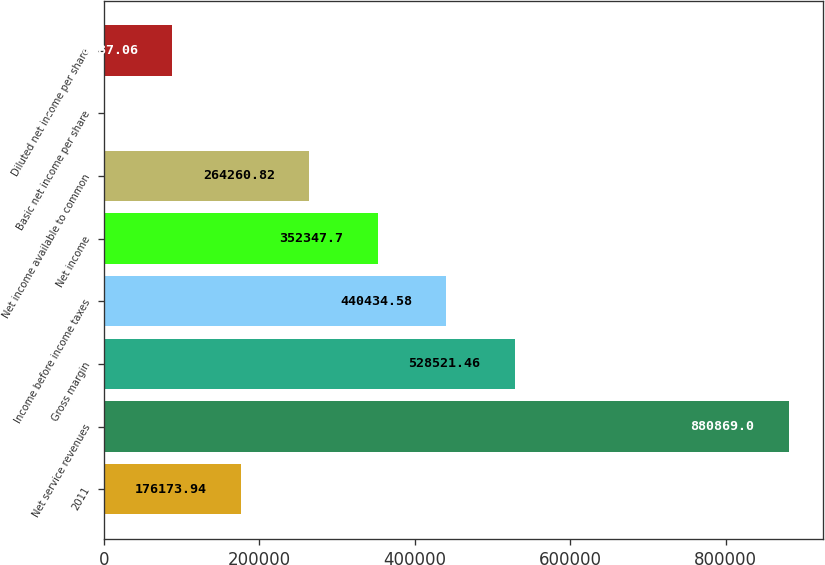Convert chart. <chart><loc_0><loc_0><loc_500><loc_500><bar_chart><fcel>2011<fcel>Net service revenues<fcel>Gross margin<fcel>Income before income taxes<fcel>Net income<fcel>Net income available to common<fcel>Basic net income per share<fcel>Diluted net income per share<nl><fcel>176174<fcel>880869<fcel>528521<fcel>440435<fcel>352348<fcel>264261<fcel>0.18<fcel>88087.1<nl></chart> 